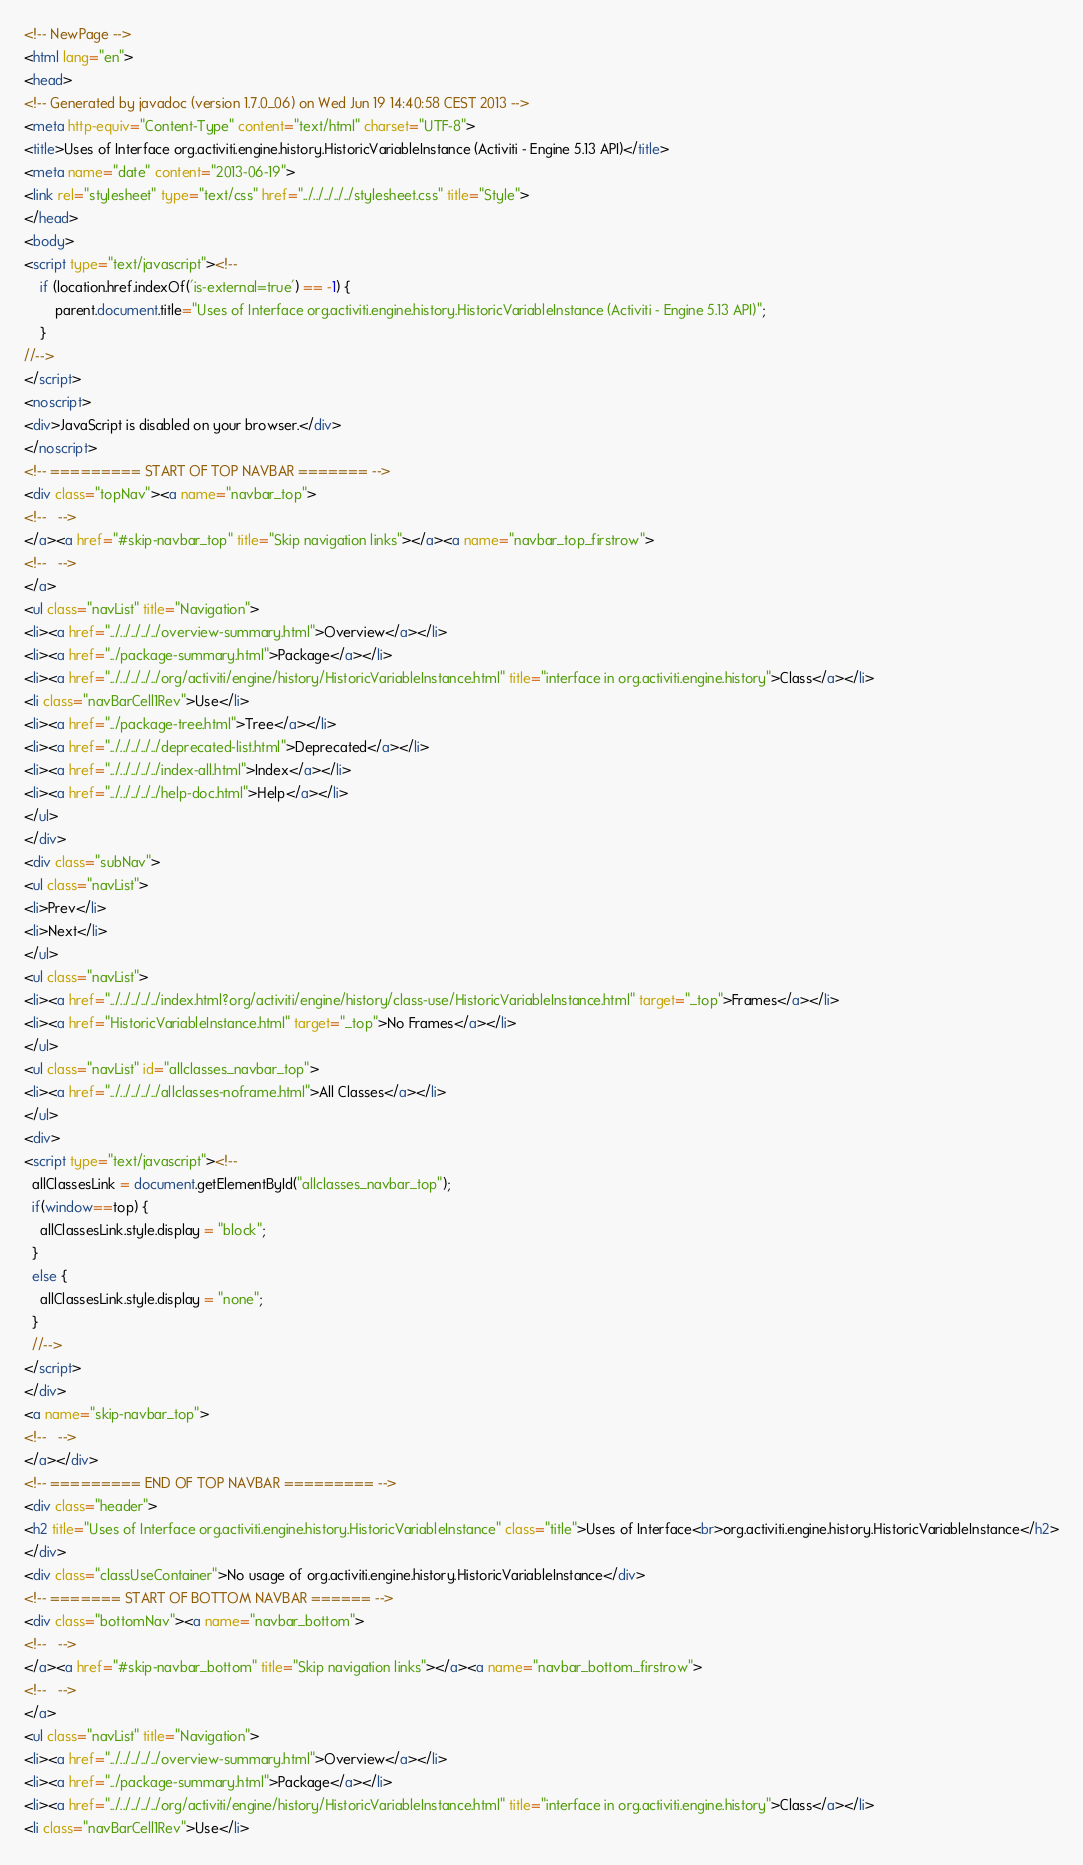<code> <loc_0><loc_0><loc_500><loc_500><_HTML_><!-- NewPage -->
<html lang="en">
<head>
<!-- Generated by javadoc (version 1.7.0_06) on Wed Jun 19 14:40:58 CEST 2013 -->
<meta http-equiv="Content-Type" content="text/html" charset="UTF-8">
<title>Uses of Interface org.activiti.engine.history.HistoricVariableInstance (Activiti - Engine 5.13 API)</title>
<meta name="date" content="2013-06-19">
<link rel="stylesheet" type="text/css" href="../../../../../stylesheet.css" title="Style">
</head>
<body>
<script type="text/javascript"><!--
    if (location.href.indexOf('is-external=true') == -1) {
        parent.document.title="Uses of Interface org.activiti.engine.history.HistoricVariableInstance (Activiti - Engine 5.13 API)";
    }
//-->
</script>
<noscript>
<div>JavaScript is disabled on your browser.</div>
</noscript>
<!-- ========= START OF TOP NAVBAR ======= -->
<div class="topNav"><a name="navbar_top">
<!--   -->
</a><a href="#skip-navbar_top" title="Skip navigation links"></a><a name="navbar_top_firstrow">
<!--   -->
</a>
<ul class="navList" title="Navigation">
<li><a href="../../../../../overview-summary.html">Overview</a></li>
<li><a href="../package-summary.html">Package</a></li>
<li><a href="../../../../../org/activiti/engine/history/HistoricVariableInstance.html" title="interface in org.activiti.engine.history">Class</a></li>
<li class="navBarCell1Rev">Use</li>
<li><a href="../package-tree.html">Tree</a></li>
<li><a href="../../../../../deprecated-list.html">Deprecated</a></li>
<li><a href="../../../../../index-all.html">Index</a></li>
<li><a href="../../../../../help-doc.html">Help</a></li>
</ul>
</div>
<div class="subNav">
<ul class="navList">
<li>Prev</li>
<li>Next</li>
</ul>
<ul class="navList">
<li><a href="../../../../../index.html?org/activiti/engine/history/class-use/HistoricVariableInstance.html" target="_top">Frames</a></li>
<li><a href="HistoricVariableInstance.html" target="_top">No Frames</a></li>
</ul>
<ul class="navList" id="allclasses_navbar_top">
<li><a href="../../../../../allclasses-noframe.html">All Classes</a></li>
</ul>
<div>
<script type="text/javascript"><!--
  allClassesLink = document.getElementById("allclasses_navbar_top");
  if(window==top) {
    allClassesLink.style.display = "block";
  }
  else {
    allClassesLink.style.display = "none";
  }
  //-->
</script>
</div>
<a name="skip-navbar_top">
<!--   -->
</a></div>
<!-- ========= END OF TOP NAVBAR ========= -->
<div class="header">
<h2 title="Uses of Interface org.activiti.engine.history.HistoricVariableInstance" class="title">Uses of Interface<br>org.activiti.engine.history.HistoricVariableInstance</h2>
</div>
<div class="classUseContainer">No usage of org.activiti.engine.history.HistoricVariableInstance</div>
<!-- ======= START OF BOTTOM NAVBAR ====== -->
<div class="bottomNav"><a name="navbar_bottom">
<!--   -->
</a><a href="#skip-navbar_bottom" title="Skip navigation links"></a><a name="navbar_bottom_firstrow">
<!--   -->
</a>
<ul class="navList" title="Navigation">
<li><a href="../../../../../overview-summary.html">Overview</a></li>
<li><a href="../package-summary.html">Package</a></li>
<li><a href="../../../../../org/activiti/engine/history/HistoricVariableInstance.html" title="interface in org.activiti.engine.history">Class</a></li>
<li class="navBarCell1Rev">Use</li></code> 